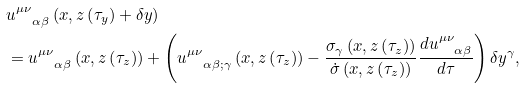<formula> <loc_0><loc_0><loc_500><loc_500>& u ^ { \mu \nu } _ { \quad \alpha \beta } \left ( x , z \left ( \tau _ { y } \right ) + \delta y \right ) \\ & = u ^ { \mu \nu } _ { \quad \alpha \beta } \left ( x , z \left ( \tau _ { z } \right ) \right ) + \left ( u ^ { \mu \nu } _ { \quad \alpha \beta ; \gamma } \left ( x , z \left ( \tau _ { z } \right ) \right ) - \frac { \sigma _ { \gamma } \left ( x , z \left ( \tau _ { z } \right ) \right ) } { \dot { \sigma } \left ( x , z \left ( \tau _ { z } \right ) \right ) } \frac { d u ^ { \mu \nu } _ { \quad \alpha \beta } } { d \tau } \right ) \delta y ^ { \gamma } ,</formula> 